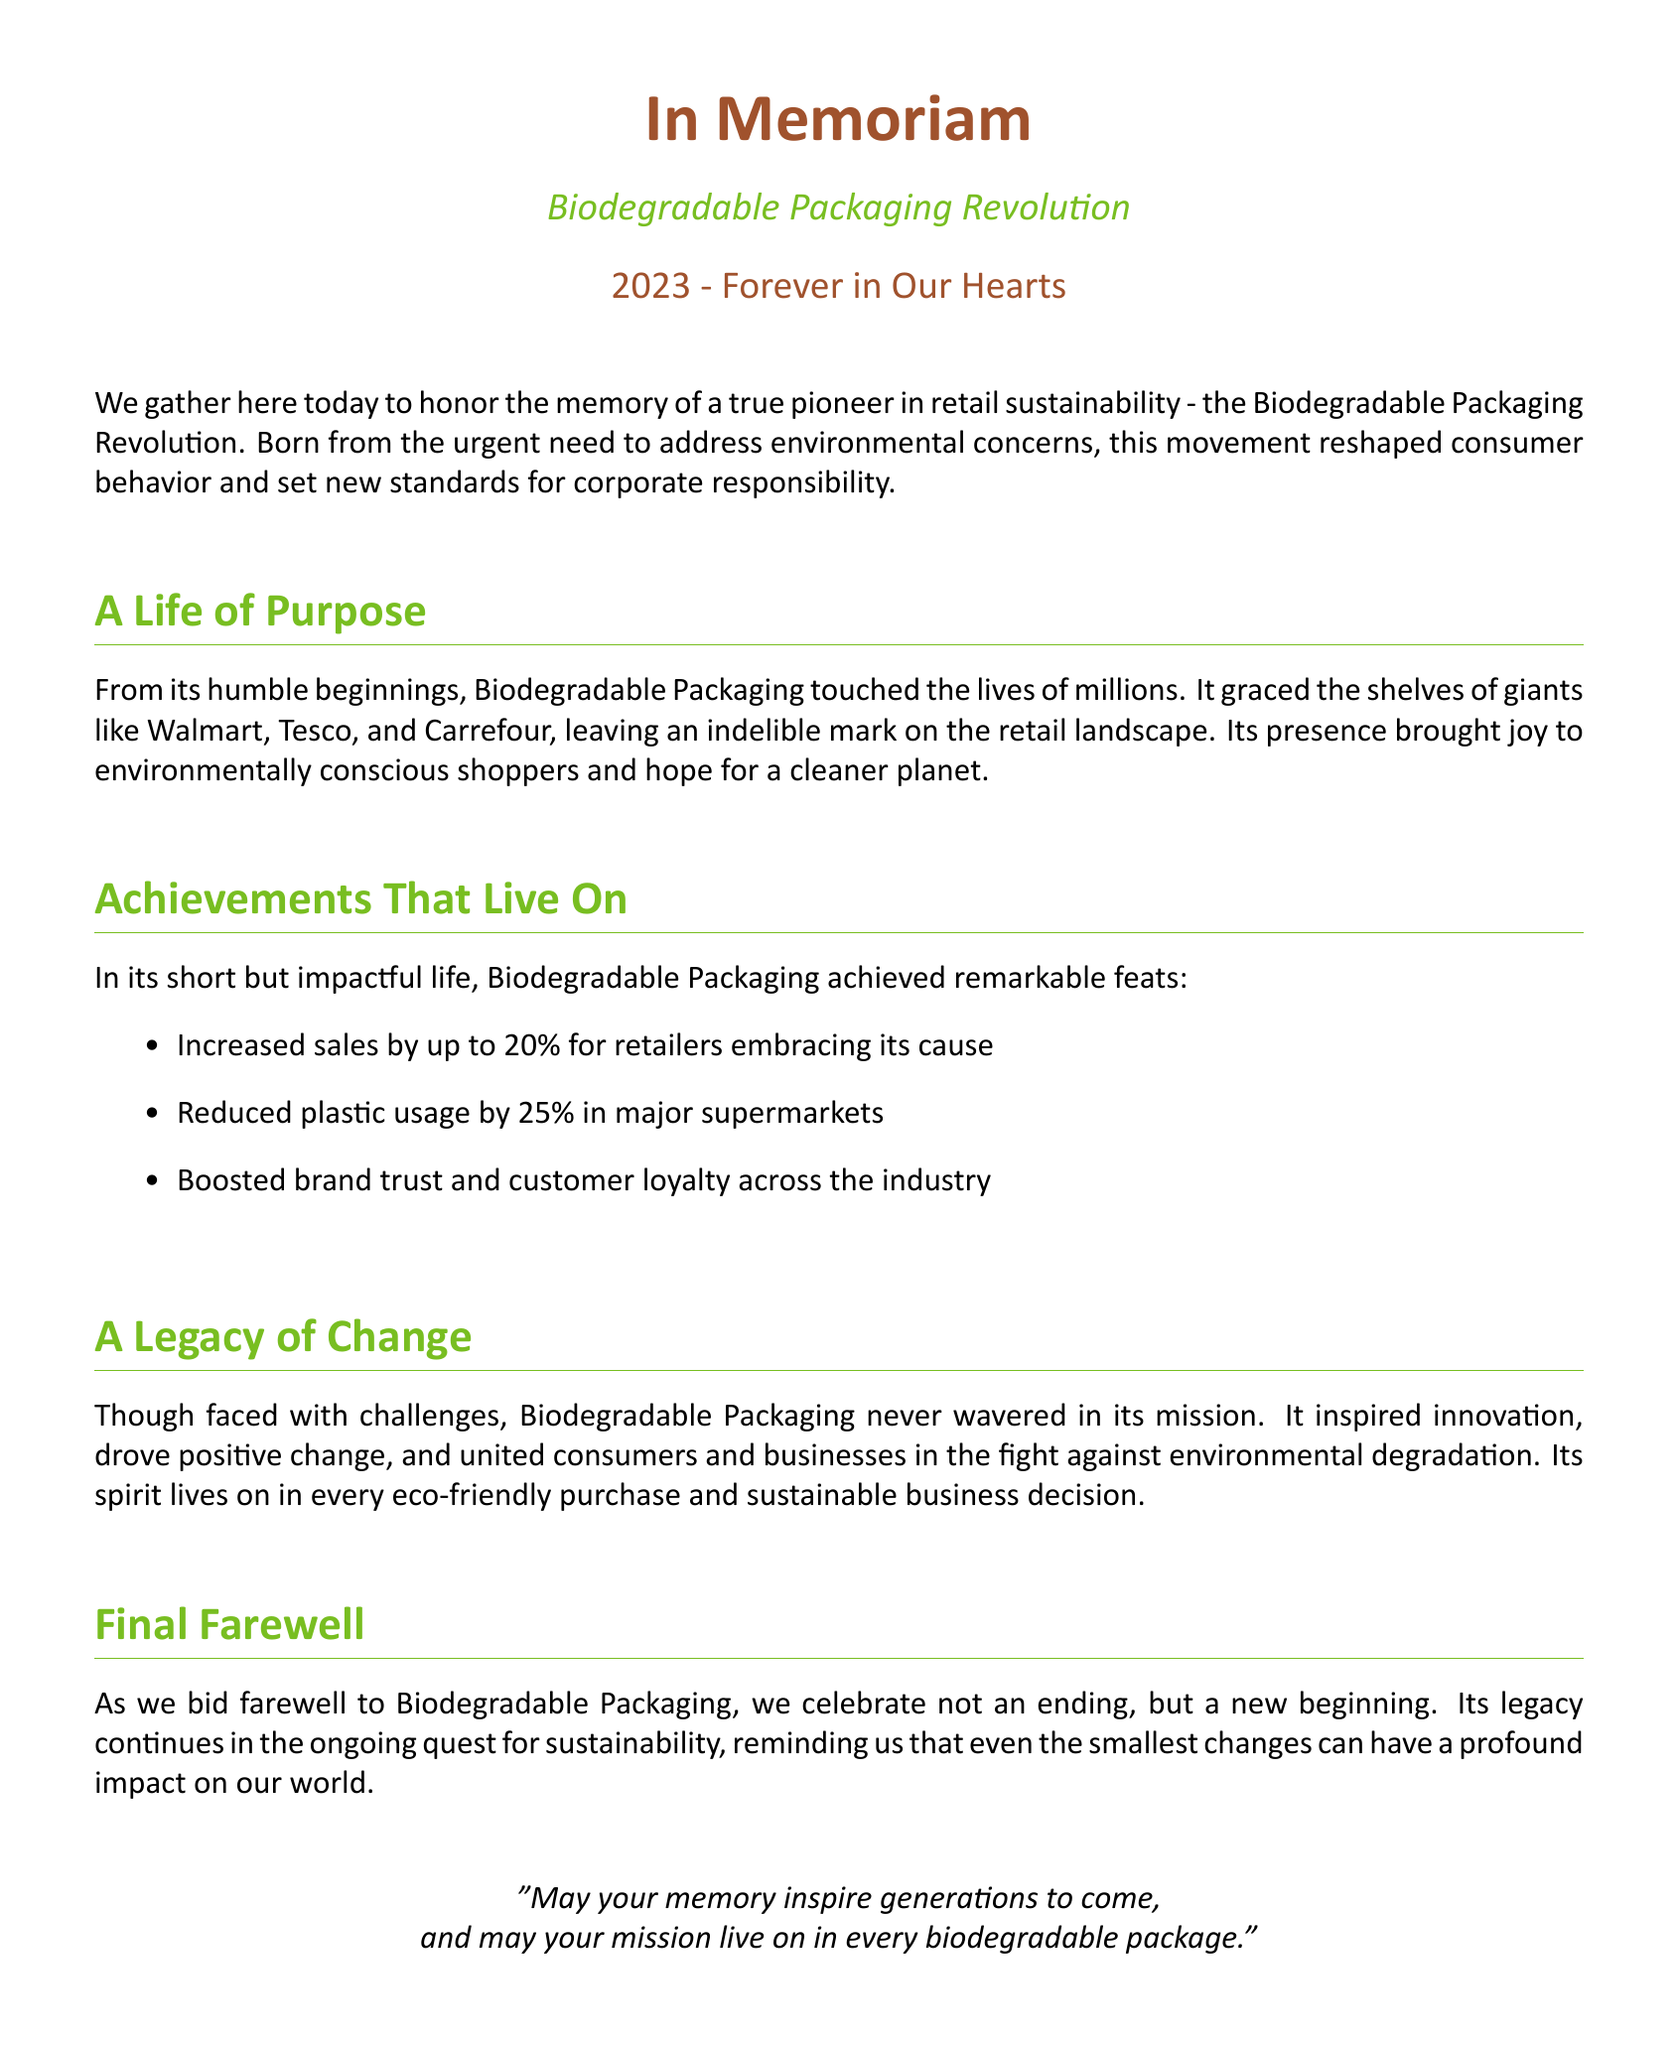What is the title of the document? The title of the document is presented at the beginning of the eulogy as a tribute to the subject, which is the "Biodegradable Packaging Revolution."
Answer: Biodegradable Packaging Revolution What year did the Biodegradable Packaging Revolution begin? The document refers to the year 2023 as significant for the Biodegradable Packaging Revolution.
Answer: 2023 Which retailers are mentioned in the eulogy? The eulogy highlights major retailers that adopted biodegradable packaging including Walmart, Tesco, and Carrefour.
Answer: Walmart, Tesco, Carrefour What was the sales increase percentage for retailers adopting biodegradable packaging? It states that retailers embracing biodegradable packaging saw an increase in sales up to 20 percent.
Answer: 20% By what percentage did plastic usage reduce in major supermarkets? The document notes that major supermarkets reduced plastic usage by 25 percent due to biodegradable packaging.
Answer: 25% What effect did biodegradable packaging have on brand trust? The eulogy describes that it boosted brand trust and customer loyalty across the industry.
Answer: Boosted band trust and customer loyalty What is the message in the final farewell quote? The last quote emphasizes the inspiring nature of the memory and mission of biodegradable packaging, indicating it should continue influencing future generations.
Answer: Inspire generations to come What is the overall theme of the document? The overarching theme emphasizes sustainability, change, and the impact of biodegradable packaging on consumer behavior and corporate responsibility.
Answer: Sustainability and change 